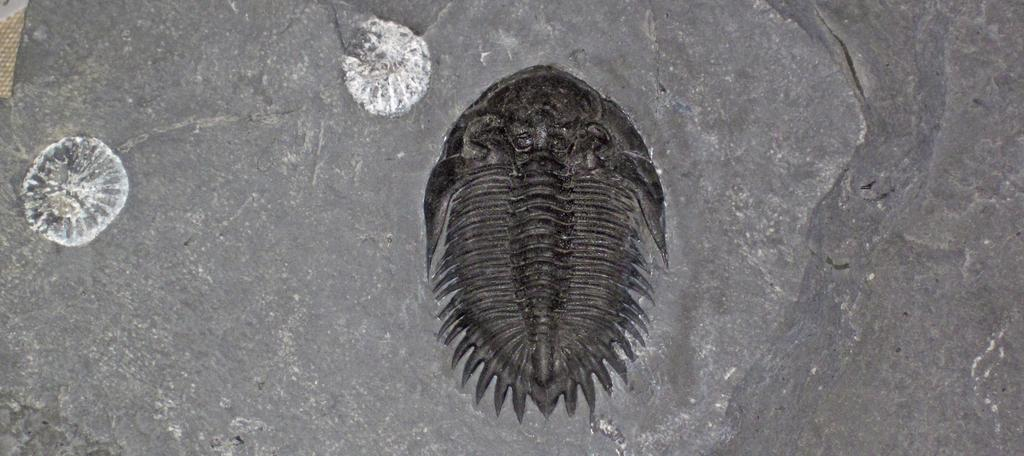What is the main subject in the center of the image? There is a fish structure in the center of the image. Has the image been altered in any way? Yes, the image has been edited. What color is the background of the image? The background of the image is grey. What type of clouds can be seen in the image? There are no clouds present in the image, as the background is grey and not a sky with clouds. 